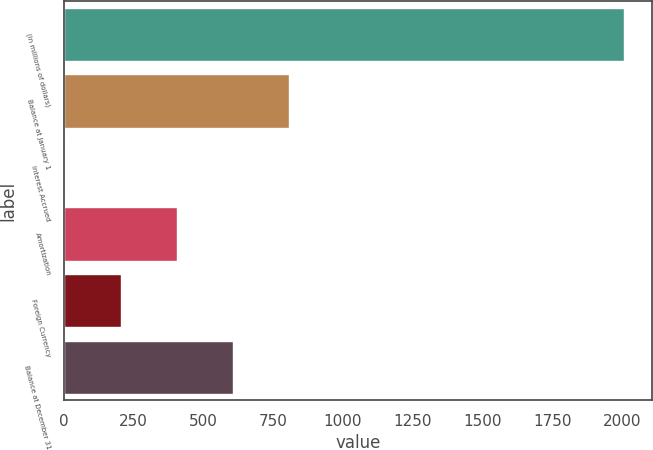Convert chart to OTSL. <chart><loc_0><loc_0><loc_500><loc_500><bar_chart><fcel>(in millions of dollars)<fcel>Balance at January 1<fcel>Interest Accrued<fcel>Amortization<fcel>Foreign Currency<fcel>Balance at December 31<nl><fcel>2006<fcel>805.16<fcel>4.6<fcel>404.88<fcel>204.74<fcel>605.02<nl></chart> 